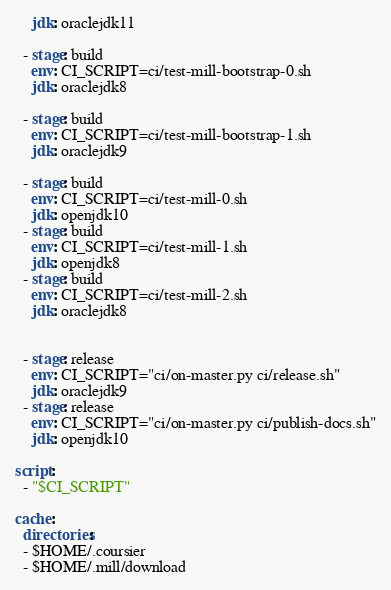Convert code to text. <code><loc_0><loc_0><loc_500><loc_500><_YAML_>    jdk: oraclejdk11

  - stage: build
    env: CI_SCRIPT=ci/test-mill-bootstrap-0.sh
    jdk: oraclejdk8

  - stage: build
    env: CI_SCRIPT=ci/test-mill-bootstrap-1.sh
    jdk: oraclejdk9

  - stage: build
    env: CI_SCRIPT=ci/test-mill-0.sh
    jdk: openjdk10
  - stage: build
    env: CI_SCRIPT=ci/test-mill-1.sh
    jdk: openjdk8
  - stage: build
    env: CI_SCRIPT=ci/test-mill-2.sh
    jdk: oraclejdk8


  - stage: release
    env: CI_SCRIPT="ci/on-master.py ci/release.sh"
    jdk: oraclejdk9
  - stage: release
    env: CI_SCRIPT="ci/on-master.py ci/publish-docs.sh"
    jdk: openjdk10

script:
  - "$CI_SCRIPT"

cache:
  directories:
  - $HOME/.coursier
  - $HOME/.mill/download
</code> 